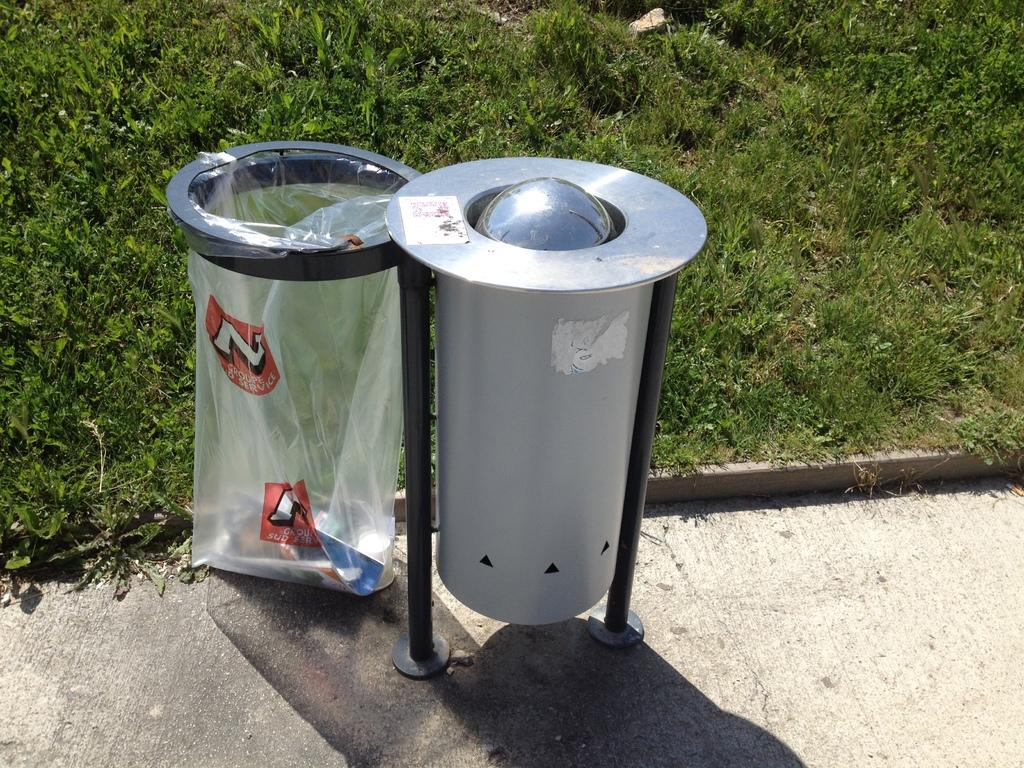<image>
Summarize the visual content of the image. A trashbag outside of a trash can that says groupe sud service 